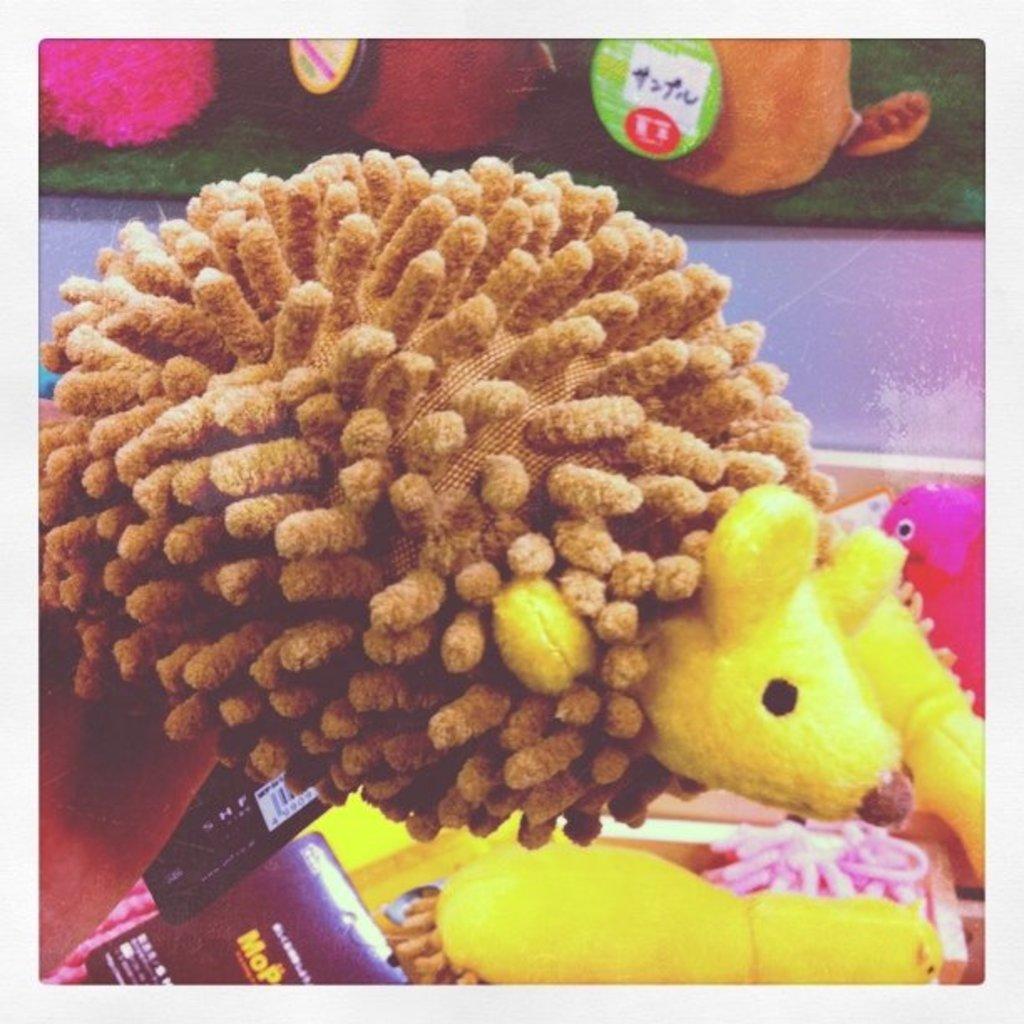Describe this image in one or two sentences. We can see toys and we can see stickers on these two toys. 